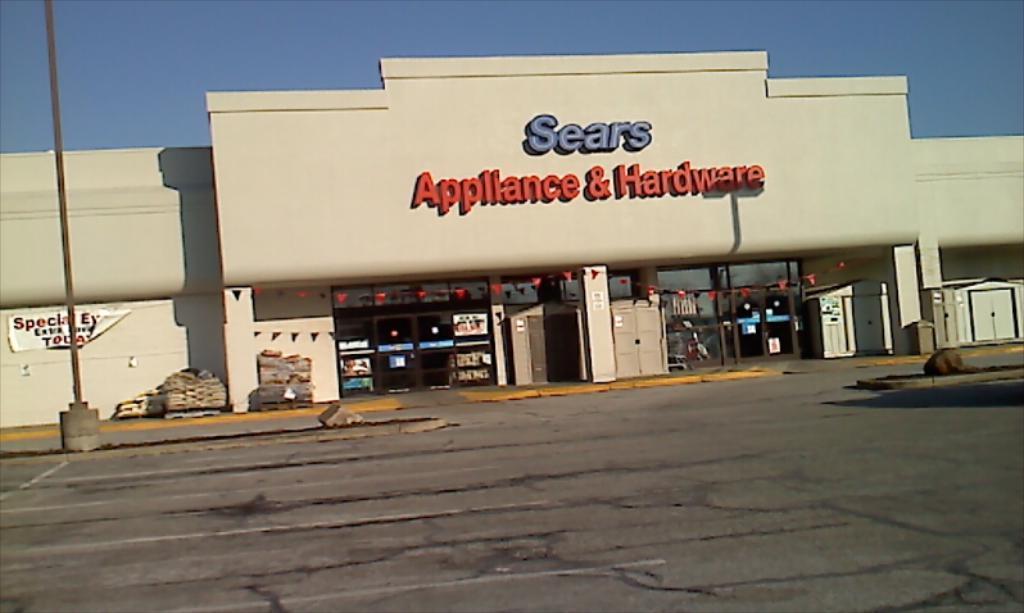Could you give a brief overview of what you see in this image? In this image I can see a building. On the building I can see some names on it. Here I can see a pole. In the background I can see the sky. 